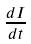Convert formula to latex. <formula><loc_0><loc_0><loc_500><loc_500>\frac { d I } { d t }</formula> 